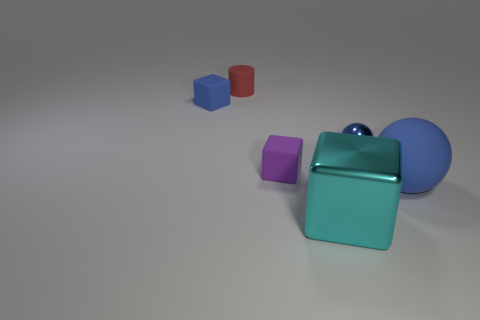There is a blue ball behind the purple rubber thing; what number of purple matte blocks are behind it?
Your answer should be compact. 0. How many other things are there of the same size as the purple rubber block?
Ensure brevity in your answer.  3. How many things are small things or objects that are behind the tiny blue ball?
Provide a succinct answer. 4. Is the number of large blue matte things less than the number of cyan cylinders?
Make the answer very short. No. There is a cube in front of the blue object that is in front of the small metal sphere; what is its color?
Offer a very short reply. Cyan. There is a purple object that is the same shape as the large cyan thing; what is its material?
Provide a succinct answer. Rubber. What number of rubber things are either big purple objects or tiny red cylinders?
Your response must be concise. 1. Does the large object that is in front of the big blue rubber object have the same material as the small blue object right of the small purple block?
Ensure brevity in your answer.  Yes. Are there any big blue matte cylinders?
Your answer should be compact. No. Is the shape of the large thing on the right side of the big cyan thing the same as the blue rubber thing that is left of the purple object?
Offer a terse response. No. 